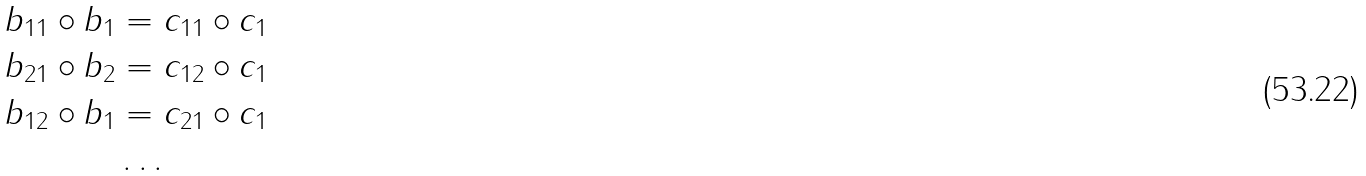<formula> <loc_0><loc_0><loc_500><loc_500>b _ { 1 1 } \circ b _ { 1 } & = c _ { 1 1 } \circ c _ { 1 } \\ b _ { 2 1 } \circ b _ { 2 } & = c _ { 1 2 } \circ c _ { 1 } \\ b _ { 1 2 } \circ b _ { 1 } & = c _ { 2 1 } \circ c _ { 1 } \\ & \dots</formula> 